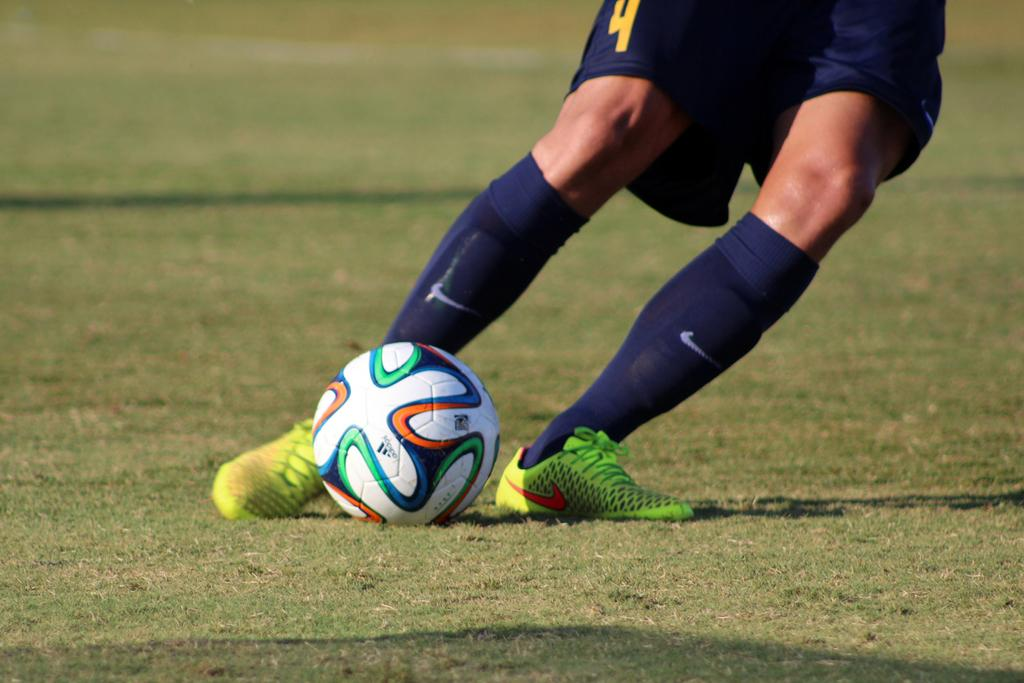<image>
Give a short and clear explanation of the subsequent image. Lower half of a soccer player numbered 4 is shown as he's about to kick the ball. 